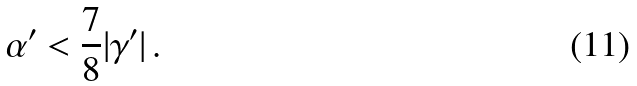<formula> <loc_0><loc_0><loc_500><loc_500>\alpha ^ { \prime } < \frac { 7 } { 8 } | \gamma ^ { \prime } | \, .</formula> 